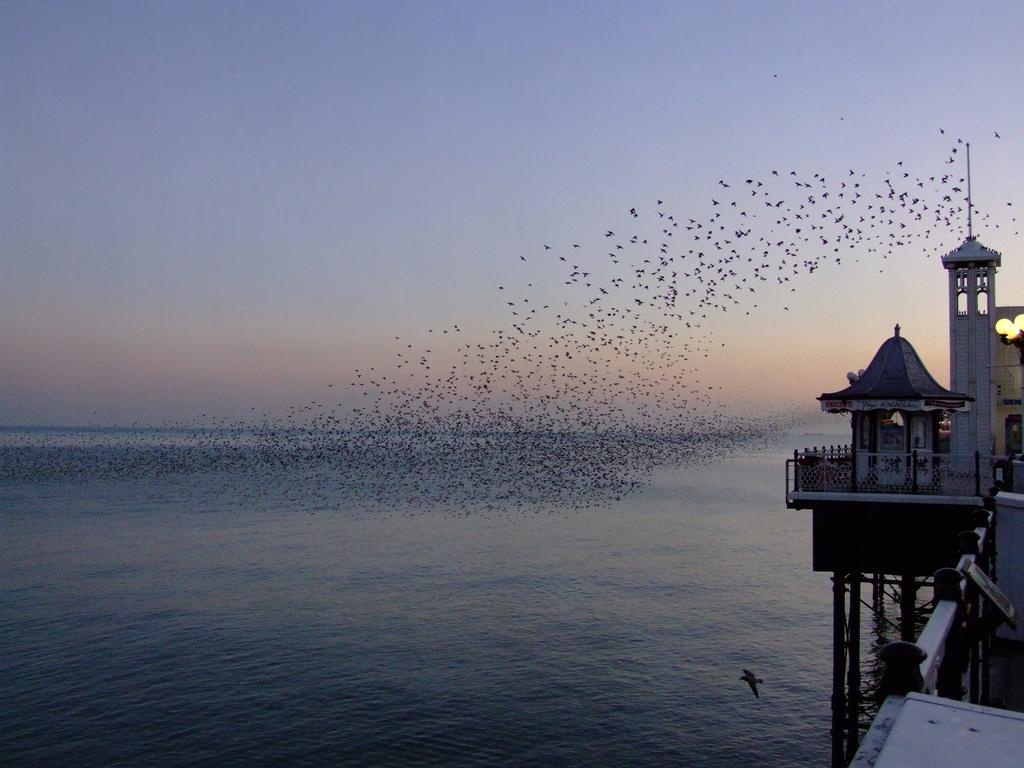What is located on the left side of the image? There is water on the left side of the image. What can be seen on the right side of the image? There is a structure on the water on the right side of the image. What is visible in the middle of the image? The sky is visible in the middle of the image. How many clocks are hanging on the structure in the image? There are no clocks visible in the image; it only features water, a structure, and the sky. What type of action is taking place in the image? The image is a still image, so there is no action taking place. 